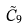Convert formula to latex. <formula><loc_0><loc_0><loc_500><loc_500>\tilde { C } _ { 9 }</formula> 